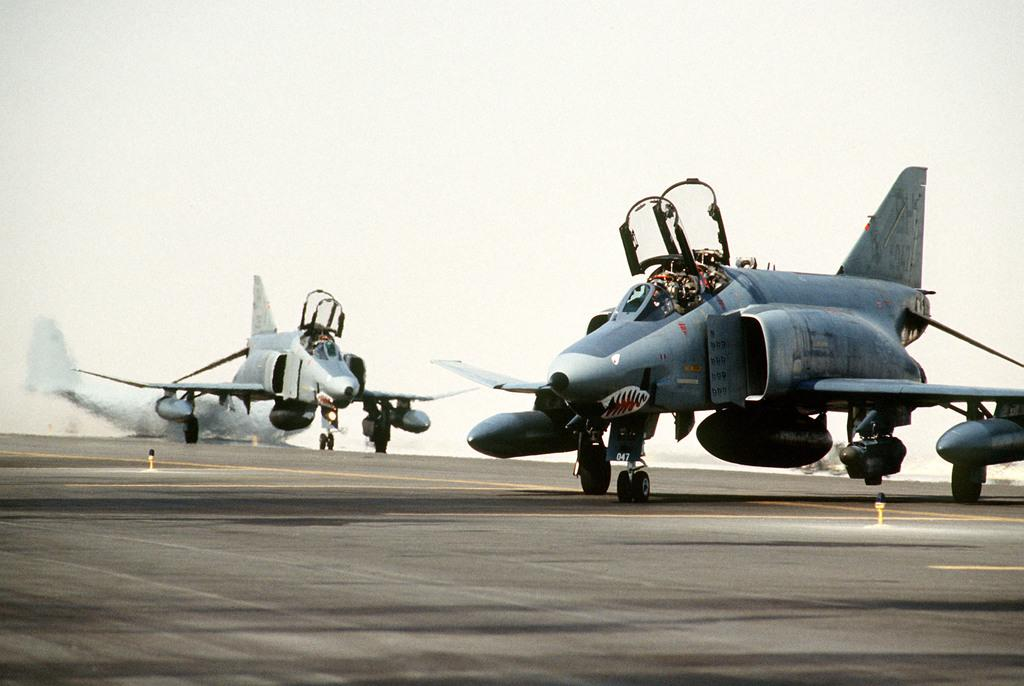What type of vehicles are in the image? There are jet planes in the image. Where are the jet planes located? The jet planes are on a runway. What type of sail can be seen on the jet planes in the image? There is no sail present on the jet planes in the image, as they are not sailing vessels. How is the distribution of the jet planes managed on the runway in the image? The image does not provide information about the distribution of the jet planes on the runway. 